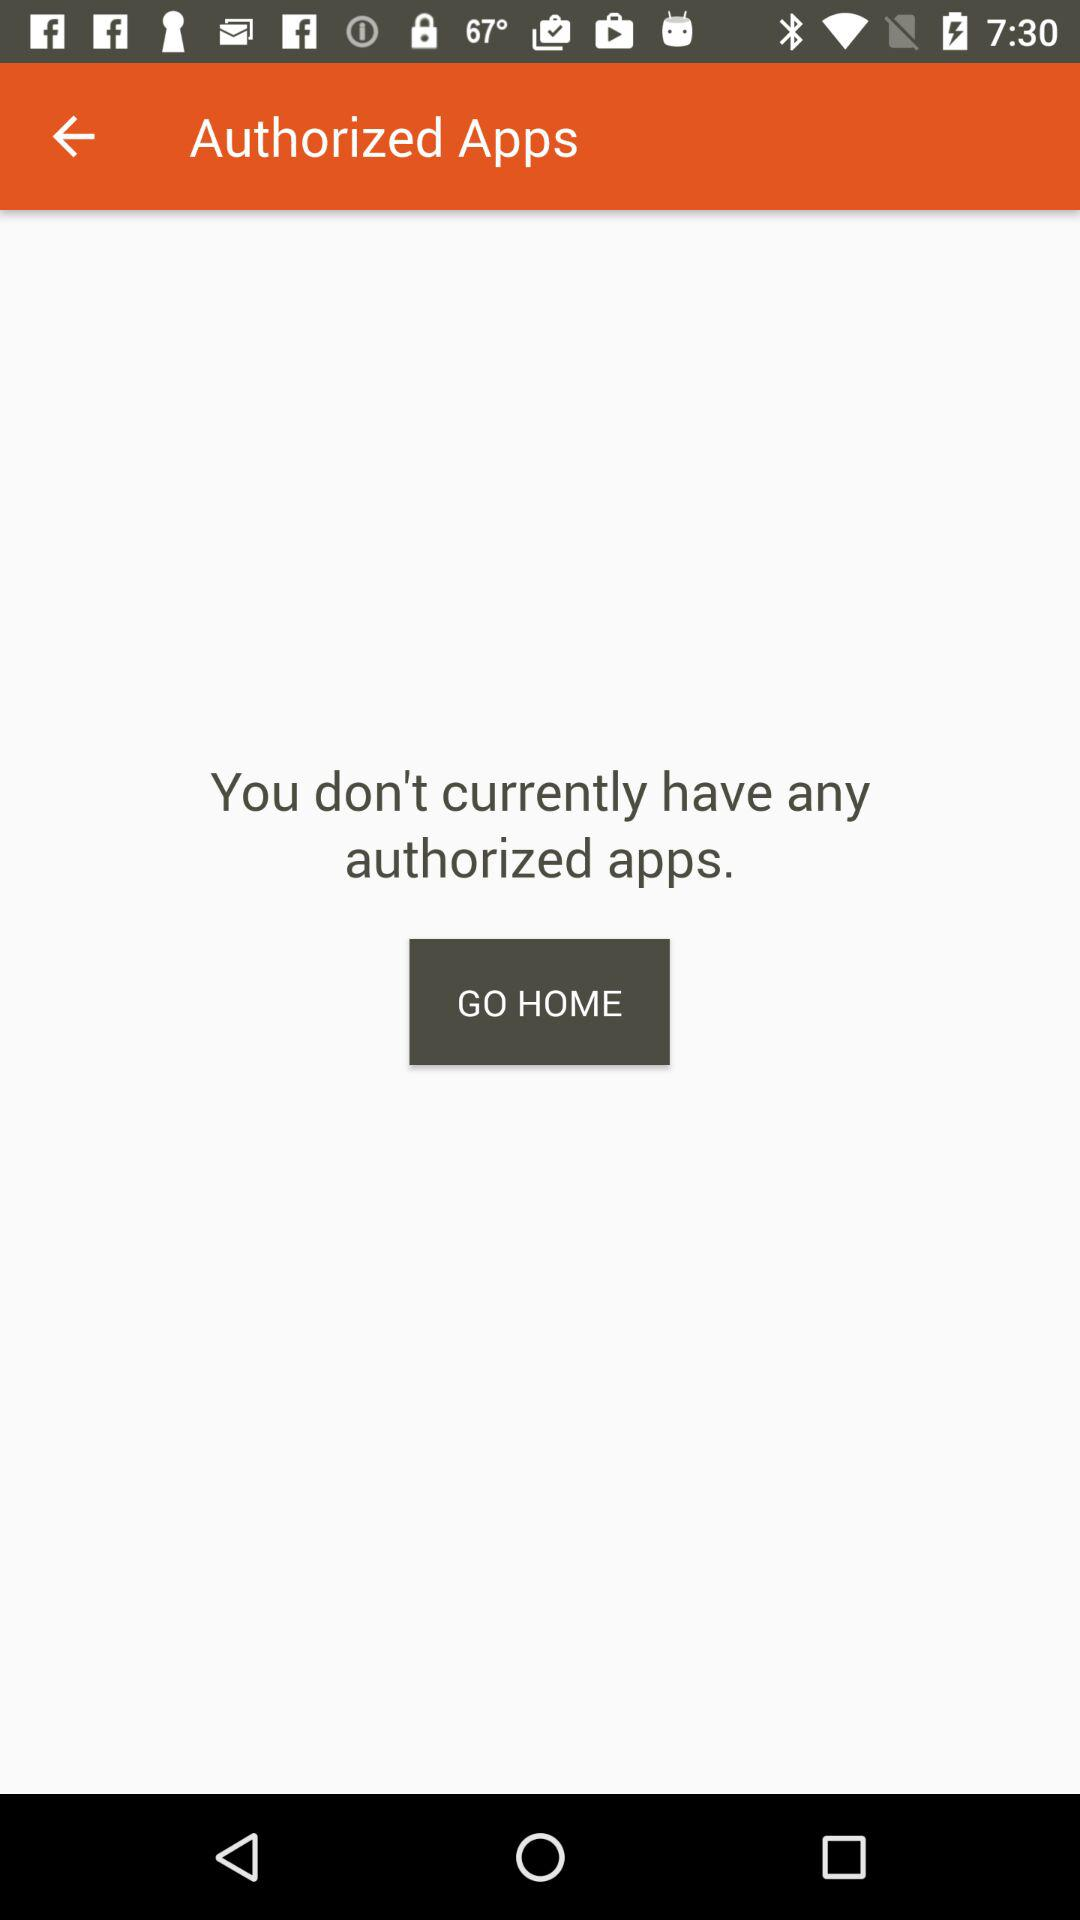How many authorized apps do I have?
Answer the question using a single word or phrase. 0 